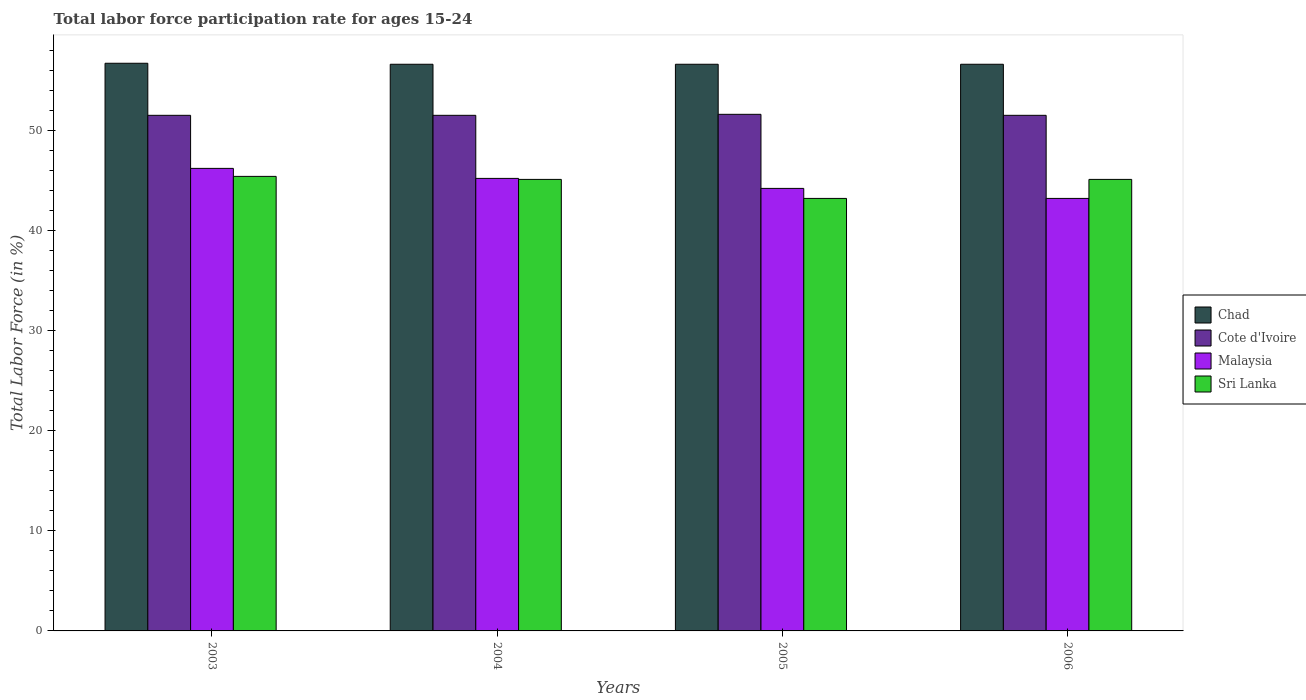How many different coloured bars are there?
Ensure brevity in your answer.  4. Are the number of bars per tick equal to the number of legend labels?
Make the answer very short. Yes. Are the number of bars on each tick of the X-axis equal?
Make the answer very short. Yes. How many bars are there on the 2nd tick from the left?
Give a very brief answer. 4. How many bars are there on the 1st tick from the right?
Offer a terse response. 4. What is the label of the 4th group of bars from the left?
Ensure brevity in your answer.  2006. What is the labor force participation rate in Sri Lanka in 2003?
Your answer should be very brief. 45.4. Across all years, what is the maximum labor force participation rate in Cote d'Ivoire?
Your answer should be compact. 51.6. Across all years, what is the minimum labor force participation rate in Sri Lanka?
Your answer should be compact. 43.2. In which year was the labor force participation rate in Malaysia minimum?
Provide a succinct answer. 2006. What is the total labor force participation rate in Sri Lanka in the graph?
Give a very brief answer. 178.8. What is the difference between the labor force participation rate in Cote d'Ivoire in 2005 and that in 2006?
Your answer should be very brief. 0.1. What is the difference between the labor force participation rate in Malaysia in 2003 and the labor force participation rate in Chad in 2004?
Your answer should be very brief. -10.4. What is the average labor force participation rate in Cote d'Ivoire per year?
Give a very brief answer. 51.52. In the year 2003, what is the difference between the labor force participation rate in Sri Lanka and labor force participation rate in Chad?
Give a very brief answer. -11.3. What is the ratio of the labor force participation rate in Sri Lanka in 2004 to that in 2005?
Make the answer very short. 1.04. Is the difference between the labor force participation rate in Sri Lanka in 2003 and 2004 greater than the difference between the labor force participation rate in Chad in 2003 and 2004?
Your response must be concise. Yes. What is the difference between the highest and the second highest labor force participation rate in Sri Lanka?
Your answer should be compact. 0.3. What is the difference between the highest and the lowest labor force participation rate in Chad?
Your answer should be very brief. 0.1. In how many years, is the labor force participation rate in Sri Lanka greater than the average labor force participation rate in Sri Lanka taken over all years?
Make the answer very short. 3. Is the sum of the labor force participation rate in Cote d'Ivoire in 2004 and 2006 greater than the maximum labor force participation rate in Chad across all years?
Ensure brevity in your answer.  Yes. What does the 1st bar from the left in 2004 represents?
Provide a short and direct response. Chad. What does the 2nd bar from the right in 2006 represents?
Your response must be concise. Malaysia. Is it the case that in every year, the sum of the labor force participation rate in Cote d'Ivoire and labor force participation rate in Chad is greater than the labor force participation rate in Malaysia?
Provide a succinct answer. Yes. How many bars are there?
Give a very brief answer. 16. What is the difference between two consecutive major ticks on the Y-axis?
Your answer should be compact. 10. How many legend labels are there?
Give a very brief answer. 4. What is the title of the graph?
Offer a very short reply. Total labor force participation rate for ages 15-24. What is the label or title of the Y-axis?
Provide a short and direct response. Total Labor Force (in %). What is the Total Labor Force (in %) of Chad in 2003?
Make the answer very short. 56.7. What is the Total Labor Force (in %) of Cote d'Ivoire in 2003?
Keep it short and to the point. 51.5. What is the Total Labor Force (in %) of Malaysia in 2003?
Provide a short and direct response. 46.2. What is the Total Labor Force (in %) in Sri Lanka in 2003?
Keep it short and to the point. 45.4. What is the Total Labor Force (in %) of Chad in 2004?
Offer a terse response. 56.6. What is the Total Labor Force (in %) of Cote d'Ivoire in 2004?
Your response must be concise. 51.5. What is the Total Labor Force (in %) in Malaysia in 2004?
Give a very brief answer. 45.2. What is the Total Labor Force (in %) in Sri Lanka in 2004?
Offer a terse response. 45.1. What is the Total Labor Force (in %) in Chad in 2005?
Your answer should be very brief. 56.6. What is the Total Labor Force (in %) of Cote d'Ivoire in 2005?
Provide a succinct answer. 51.6. What is the Total Labor Force (in %) of Malaysia in 2005?
Make the answer very short. 44.2. What is the Total Labor Force (in %) of Sri Lanka in 2005?
Make the answer very short. 43.2. What is the Total Labor Force (in %) in Chad in 2006?
Provide a succinct answer. 56.6. What is the Total Labor Force (in %) in Cote d'Ivoire in 2006?
Provide a succinct answer. 51.5. What is the Total Labor Force (in %) of Malaysia in 2006?
Make the answer very short. 43.2. What is the Total Labor Force (in %) in Sri Lanka in 2006?
Provide a short and direct response. 45.1. Across all years, what is the maximum Total Labor Force (in %) of Chad?
Make the answer very short. 56.7. Across all years, what is the maximum Total Labor Force (in %) of Cote d'Ivoire?
Keep it short and to the point. 51.6. Across all years, what is the maximum Total Labor Force (in %) in Malaysia?
Offer a terse response. 46.2. Across all years, what is the maximum Total Labor Force (in %) of Sri Lanka?
Offer a very short reply. 45.4. Across all years, what is the minimum Total Labor Force (in %) in Chad?
Your response must be concise. 56.6. Across all years, what is the minimum Total Labor Force (in %) in Cote d'Ivoire?
Offer a terse response. 51.5. Across all years, what is the minimum Total Labor Force (in %) of Malaysia?
Offer a very short reply. 43.2. Across all years, what is the minimum Total Labor Force (in %) of Sri Lanka?
Make the answer very short. 43.2. What is the total Total Labor Force (in %) of Chad in the graph?
Your response must be concise. 226.5. What is the total Total Labor Force (in %) in Cote d'Ivoire in the graph?
Your answer should be compact. 206.1. What is the total Total Labor Force (in %) of Malaysia in the graph?
Offer a very short reply. 178.8. What is the total Total Labor Force (in %) in Sri Lanka in the graph?
Offer a very short reply. 178.8. What is the difference between the Total Labor Force (in %) in Chad in 2003 and that in 2004?
Your answer should be very brief. 0.1. What is the difference between the Total Labor Force (in %) in Cote d'Ivoire in 2003 and that in 2004?
Provide a short and direct response. 0. What is the difference between the Total Labor Force (in %) of Sri Lanka in 2003 and that in 2004?
Make the answer very short. 0.3. What is the difference between the Total Labor Force (in %) in Chad in 2003 and that in 2005?
Provide a short and direct response. 0.1. What is the difference between the Total Labor Force (in %) of Cote d'Ivoire in 2003 and that in 2006?
Ensure brevity in your answer.  0. What is the difference between the Total Labor Force (in %) of Malaysia in 2003 and that in 2006?
Provide a short and direct response. 3. What is the difference between the Total Labor Force (in %) of Sri Lanka in 2003 and that in 2006?
Your answer should be very brief. 0.3. What is the difference between the Total Labor Force (in %) in Chad in 2004 and that in 2005?
Provide a short and direct response. 0. What is the difference between the Total Labor Force (in %) of Malaysia in 2004 and that in 2005?
Make the answer very short. 1. What is the difference between the Total Labor Force (in %) of Sri Lanka in 2004 and that in 2005?
Keep it short and to the point. 1.9. What is the difference between the Total Labor Force (in %) of Cote d'Ivoire in 2004 and that in 2006?
Provide a succinct answer. 0. What is the difference between the Total Labor Force (in %) in Cote d'Ivoire in 2005 and that in 2006?
Keep it short and to the point. 0.1. What is the difference between the Total Labor Force (in %) in Malaysia in 2005 and that in 2006?
Ensure brevity in your answer.  1. What is the difference between the Total Labor Force (in %) of Chad in 2003 and the Total Labor Force (in %) of Malaysia in 2004?
Make the answer very short. 11.5. What is the difference between the Total Labor Force (in %) in Chad in 2003 and the Total Labor Force (in %) in Sri Lanka in 2004?
Offer a terse response. 11.6. What is the difference between the Total Labor Force (in %) in Cote d'Ivoire in 2003 and the Total Labor Force (in %) in Malaysia in 2004?
Give a very brief answer. 6.3. What is the difference between the Total Labor Force (in %) of Malaysia in 2003 and the Total Labor Force (in %) of Sri Lanka in 2004?
Keep it short and to the point. 1.1. What is the difference between the Total Labor Force (in %) of Chad in 2003 and the Total Labor Force (in %) of Cote d'Ivoire in 2005?
Provide a succinct answer. 5.1. What is the difference between the Total Labor Force (in %) in Chad in 2003 and the Total Labor Force (in %) in Malaysia in 2005?
Offer a terse response. 12.5. What is the difference between the Total Labor Force (in %) in Chad in 2003 and the Total Labor Force (in %) in Sri Lanka in 2005?
Keep it short and to the point. 13.5. What is the difference between the Total Labor Force (in %) of Cote d'Ivoire in 2003 and the Total Labor Force (in %) of Malaysia in 2005?
Your answer should be very brief. 7.3. What is the difference between the Total Labor Force (in %) in Chad in 2003 and the Total Labor Force (in %) in Cote d'Ivoire in 2006?
Make the answer very short. 5.2. What is the difference between the Total Labor Force (in %) in Chad in 2003 and the Total Labor Force (in %) in Malaysia in 2006?
Provide a short and direct response. 13.5. What is the difference between the Total Labor Force (in %) in Chad in 2003 and the Total Labor Force (in %) in Sri Lanka in 2006?
Provide a succinct answer. 11.6. What is the difference between the Total Labor Force (in %) of Cote d'Ivoire in 2003 and the Total Labor Force (in %) of Malaysia in 2006?
Give a very brief answer. 8.3. What is the difference between the Total Labor Force (in %) of Malaysia in 2003 and the Total Labor Force (in %) of Sri Lanka in 2006?
Provide a succinct answer. 1.1. What is the difference between the Total Labor Force (in %) in Chad in 2004 and the Total Labor Force (in %) in Malaysia in 2005?
Give a very brief answer. 12.4. What is the difference between the Total Labor Force (in %) of Chad in 2004 and the Total Labor Force (in %) of Sri Lanka in 2005?
Give a very brief answer. 13.4. What is the difference between the Total Labor Force (in %) in Cote d'Ivoire in 2004 and the Total Labor Force (in %) in Malaysia in 2005?
Provide a succinct answer. 7.3. What is the difference between the Total Labor Force (in %) of Cote d'Ivoire in 2004 and the Total Labor Force (in %) of Sri Lanka in 2005?
Make the answer very short. 8.3. What is the difference between the Total Labor Force (in %) in Chad in 2004 and the Total Labor Force (in %) in Malaysia in 2006?
Your answer should be compact. 13.4. What is the difference between the Total Labor Force (in %) of Cote d'Ivoire in 2004 and the Total Labor Force (in %) of Malaysia in 2006?
Provide a succinct answer. 8.3. What is the difference between the Total Labor Force (in %) of Cote d'Ivoire in 2004 and the Total Labor Force (in %) of Sri Lanka in 2006?
Ensure brevity in your answer.  6.4. What is the difference between the Total Labor Force (in %) in Chad in 2005 and the Total Labor Force (in %) in Malaysia in 2006?
Your answer should be compact. 13.4. What is the difference between the Total Labor Force (in %) of Chad in 2005 and the Total Labor Force (in %) of Sri Lanka in 2006?
Offer a very short reply. 11.5. What is the difference between the Total Labor Force (in %) in Cote d'Ivoire in 2005 and the Total Labor Force (in %) in Malaysia in 2006?
Your answer should be compact. 8.4. What is the difference between the Total Labor Force (in %) in Cote d'Ivoire in 2005 and the Total Labor Force (in %) in Sri Lanka in 2006?
Provide a short and direct response. 6.5. What is the average Total Labor Force (in %) in Chad per year?
Ensure brevity in your answer.  56.62. What is the average Total Labor Force (in %) of Cote d'Ivoire per year?
Your answer should be very brief. 51.52. What is the average Total Labor Force (in %) of Malaysia per year?
Offer a very short reply. 44.7. What is the average Total Labor Force (in %) of Sri Lanka per year?
Your answer should be very brief. 44.7. In the year 2003, what is the difference between the Total Labor Force (in %) in Chad and Total Labor Force (in %) in Cote d'Ivoire?
Ensure brevity in your answer.  5.2. In the year 2003, what is the difference between the Total Labor Force (in %) of Chad and Total Labor Force (in %) of Malaysia?
Provide a succinct answer. 10.5. In the year 2003, what is the difference between the Total Labor Force (in %) in Chad and Total Labor Force (in %) in Sri Lanka?
Ensure brevity in your answer.  11.3. In the year 2003, what is the difference between the Total Labor Force (in %) of Malaysia and Total Labor Force (in %) of Sri Lanka?
Your answer should be compact. 0.8. In the year 2004, what is the difference between the Total Labor Force (in %) in Chad and Total Labor Force (in %) in Malaysia?
Keep it short and to the point. 11.4. In the year 2004, what is the difference between the Total Labor Force (in %) of Chad and Total Labor Force (in %) of Sri Lanka?
Provide a succinct answer. 11.5. In the year 2005, what is the difference between the Total Labor Force (in %) of Cote d'Ivoire and Total Labor Force (in %) of Sri Lanka?
Ensure brevity in your answer.  8.4. In the year 2005, what is the difference between the Total Labor Force (in %) in Malaysia and Total Labor Force (in %) in Sri Lanka?
Provide a short and direct response. 1. In the year 2006, what is the difference between the Total Labor Force (in %) of Chad and Total Labor Force (in %) of Cote d'Ivoire?
Provide a succinct answer. 5.1. In the year 2006, what is the difference between the Total Labor Force (in %) in Chad and Total Labor Force (in %) in Malaysia?
Make the answer very short. 13.4. In the year 2006, what is the difference between the Total Labor Force (in %) in Chad and Total Labor Force (in %) in Sri Lanka?
Give a very brief answer. 11.5. In the year 2006, what is the difference between the Total Labor Force (in %) of Cote d'Ivoire and Total Labor Force (in %) of Sri Lanka?
Ensure brevity in your answer.  6.4. In the year 2006, what is the difference between the Total Labor Force (in %) of Malaysia and Total Labor Force (in %) of Sri Lanka?
Offer a terse response. -1.9. What is the ratio of the Total Labor Force (in %) of Chad in 2003 to that in 2004?
Offer a very short reply. 1. What is the ratio of the Total Labor Force (in %) in Cote d'Ivoire in 2003 to that in 2004?
Your answer should be very brief. 1. What is the ratio of the Total Labor Force (in %) of Malaysia in 2003 to that in 2004?
Provide a short and direct response. 1.02. What is the ratio of the Total Labor Force (in %) in Sri Lanka in 2003 to that in 2004?
Offer a very short reply. 1.01. What is the ratio of the Total Labor Force (in %) in Chad in 2003 to that in 2005?
Provide a short and direct response. 1. What is the ratio of the Total Labor Force (in %) in Cote d'Ivoire in 2003 to that in 2005?
Ensure brevity in your answer.  1. What is the ratio of the Total Labor Force (in %) in Malaysia in 2003 to that in 2005?
Offer a very short reply. 1.05. What is the ratio of the Total Labor Force (in %) in Sri Lanka in 2003 to that in 2005?
Ensure brevity in your answer.  1.05. What is the ratio of the Total Labor Force (in %) of Chad in 2003 to that in 2006?
Offer a terse response. 1. What is the ratio of the Total Labor Force (in %) of Cote d'Ivoire in 2003 to that in 2006?
Provide a short and direct response. 1. What is the ratio of the Total Labor Force (in %) in Malaysia in 2003 to that in 2006?
Offer a very short reply. 1.07. What is the ratio of the Total Labor Force (in %) in Chad in 2004 to that in 2005?
Give a very brief answer. 1. What is the ratio of the Total Labor Force (in %) of Cote d'Ivoire in 2004 to that in 2005?
Offer a terse response. 1. What is the ratio of the Total Labor Force (in %) of Malaysia in 2004 to that in 2005?
Make the answer very short. 1.02. What is the ratio of the Total Labor Force (in %) of Sri Lanka in 2004 to that in 2005?
Offer a very short reply. 1.04. What is the ratio of the Total Labor Force (in %) of Cote d'Ivoire in 2004 to that in 2006?
Offer a very short reply. 1. What is the ratio of the Total Labor Force (in %) of Malaysia in 2004 to that in 2006?
Give a very brief answer. 1.05. What is the ratio of the Total Labor Force (in %) in Sri Lanka in 2004 to that in 2006?
Your answer should be compact. 1. What is the ratio of the Total Labor Force (in %) of Cote d'Ivoire in 2005 to that in 2006?
Your response must be concise. 1. What is the ratio of the Total Labor Force (in %) of Malaysia in 2005 to that in 2006?
Your answer should be very brief. 1.02. What is the ratio of the Total Labor Force (in %) in Sri Lanka in 2005 to that in 2006?
Your answer should be compact. 0.96. What is the difference between the highest and the second highest Total Labor Force (in %) in Chad?
Provide a succinct answer. 0.1. What is the difference between the highest and the second highest Total Labor Force (in %) in Malaysia?
Keep it short and to the point. 1. What is the difference between the highest and the second highest Total Labor Force (in %) of Sri Lanka?
Give a very brief answer. 0.3. What is the difference between the highest and the lowest Total Labor Force (in %) of Cote d'Ivoire?
Give a very brief answer. 0.1. What is the difference between the highest and the lowest Total Labor Force (in %) of Sri Lanka?
Your answer should be compact. 2.2. 